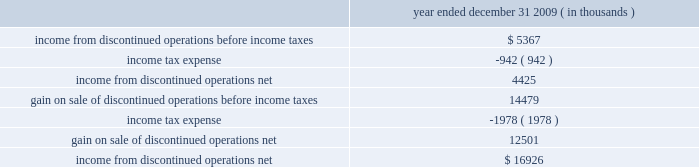$ 25.7 million in cash , including $ 4.2 million in taxes and 1373609 of hep 2019s common units having a fair value of $ 53.5 million .
Roadrunner / beeson pipelines transaction also on december 1 , 2009 , hep acquired our two newly constructed pipelines for $ 46.5 million , consisting of a 65- mile , 16-inch crude oil pipeline ( the 201croadrunner pipeline 201d ) that connects our navajo refinery lovington facility to a terminus of centurion pipeline l.p . 2019s pipeline extending between west texas and cushing , oklahoma and a 37- mile , 8-inch crude oil pipeline that connects hep 2019s new mexico crude oil gathering system to our navajo refinery lovington facility ( the 201cbeeson pipeline 201d ) .
Tulsa west loading racks transaction on august 1 , 2009 , hep acquired from us , certain truck and rail loading/unloading facilities located at our tulsa west facility for $ 17.5 million .
The racks load refined products and lube oils produced at the tulsa west facility onto rail cars and/or tanker trucks .
Lovington-artesia pipeline transaction on june 1 , 2009 , hep acquired our newly constructed , 16-inch intermediate pipeline for $ 34.2 million that runs 65 miles from our navajo refinery 2019s crude oil distillation and vacuum facilities in lovington , new mexico to its petroleum refinery located in artesia , new mexico .
Slc pipeline joint venture interest on march 1 , 2009 , hep acquired a 25% ( 25 % ) joint venture interest in the slc pipeline , a new 95-mile intrastate pipeline system jointly owned with plains .
The slc pipeline commenced operations effective march 2009 and allows various refineries in the salt lake city area , including our woods cross refinery , to ship crude oil into the salt lake city area from the utah terminus of the frontier pipeline as well as crude oil flowing from wyoming and utah via plains 2019 rocky mountain pipeline .
Hep 2019s capitalized joint venture contribution was $ 25.5 million .
Rio grande pipeline sale on december 1 , 2009 , hep sold its 70% ( 70 % ) interest in rio grande pipeline company ( 201crio grande 201d ) to a subsidiary of enterprise products partners lp for $ 35 million .
Results of operations of rio grande are presented in discontinued operations .
In accounting for this sale , hep recorded a gain of $ 14.5 million and a receivable of $ 2.2 million representing its final distribution from rio grande .
The recorded net asset balance of rio grande at december 1 , 2009 , was $ 22.7 million , consisting of cash of $ 3.1 million , $ 29.9 million in properties and equipment , net and $ 10.3 million in equity , representing bp , plc 2019s 30% ( 30 % ) noncontrolling interest .
The table provides income statement information related to hep 2019s discontinued operations : year ended december 31 , 2009 ( in thousands ) .
Transportation agreements hep serves our refineries under long-term pipeline and terminal , tankage and throughput agreements expiring in 2019 through 2026 .
Under these agreements , we pay hep fees to transport , store and throughput volumes of refined product and crude oil on hep 2019s pipeline and terminal , tankage and loading rack facilities that result in minimum annual payments to hep .
Under these agreements , the agreed upon tariff rates are subject to annual tariff rate adjustments on july 1 at a rate based upon the percentage change in producer price index ( 201cppi 201d ) or federal energy .
According to line 1 , how much is each individual hep common unit worth? 
Computations: ((53.5 - (25.7 + 4.2)) / 1373609)
Answer: 2e-05. $ 25.7 million in cash , including $ 4.2 million in taxes and 1373609 of hep 2019s common units having a fair value of $ 53.5 million .
Roadrunner / beeson pipelines transaction also on december 1 , 2009 , hep acquired our two newly constructed pipelines for $ 46.5 million , consisting of a 65- mile , 16-inch crude oil pipeline ( the 201croadrunner pipeline 201d ) that connects our navajo refinery lovington facility to a terminus of centurion pipeline l.p . 2019s pipeline extending between west texas and cushing , oklahoma and a 37- mile , 8-inch crude oil pipeline that connects hep 2019s new mexico crude oil gathering system to our navajo refinery lovington facility ( the 201cbeeson pipeline 201d ) .
Tulsa west loading racks transaction on august 1 , 2009 , hep acquired from us , certain truck and rail loading/unloading facilities located at our tulsa west facility for $ 17.5 million .
The racks load refined products and lube oils produced at the tulsa west facility onto rail cars and/or tanker trucks .
Lovington-artesia pipeline transaction on june 1 , 2009 , hep acquired our newly constructed , 16-inch intermediate pipeline for $ 34.2 million that runs 65 miles from our navajo refinery 2019s crude oil distillation and vacuum facilities in lovington , new mexico to its petroleum refinery located in artesia , new mexico .
Slc pipeline joint venture interest on march 1 , 2009 , hep acquired a 25% ( 25 % ) joint venture interest in the slc pipeline , a new 95-mile intrastate pipeline system jointly owned with plains .
The slc pipeline commenced operations effective march 2009 and allows various refineries in the salt lake city area , including our woods cross refinery , to ship crude oil into the salt lake city area from the utah terminus of the frontier pipeline as well as crude oil flowing from wyoming and utah via plains 2019 rocky mountain pipeline .
Hep 2019s capitalized joint venture contribution was $ 25.5 million .
Rio grande pipeline sale on december 1 , 2009 , hep sold its 70% ( 70 % ) interest in rio grande pipeline company ( 201crio grande 201d ) to a subsidiary of enterprise products partners lp for $ 35 million .
Results of operations of rio grande are presented in discontinued operations .
In accounting for this sale , hep recorded a gain of $ 14.5 million and a receivable of $ 2.2 million representing its final distribution from rio grande .
The recorded net asset balance of rio grande at december 1 , 2009 , was $ 22.7 million , consisting of cash of $ 3.1 million , $ 29.9 million in properties and equipment , net and $ 10.3 million in equity , representing bp , plc 2019s 30% ( 30 % ) noncontrolling interest .
The table provides income statement information related to hep 2019s discontinued operations : year ended december 31 , 2009 ( in thousands ) .
Transportation agreements hep serves our refineries under long-term pipeline and terminal , tankage and throughput agreements expiring in 2019 through 2026 .
Under these agreements , we pay hep fees to transport , store and throughput volumes of refined product and crude oil on hep 2019s pipeline and terminal , tankage and loading rack facilities that result in minimum annual payments to hep .
Under these agreements , the agreed upon tariff rates are subject to annual tariff rate adjustments on july 1 at a rate based upon the percentage change in producer price index ( 201cppi 201d ) or federal energy .
Of the recorded net asset balance of rio grande at december 1 , 2009 , what percentage was cash? 
Computations: (3.1 / 22.7)
Answer: 0.13656. 